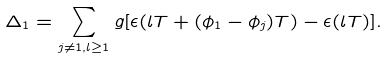Convert formula to latex. <formula><loc_0><loc_0><loc_500><loc_500>\Delta _ { 1 } = \sum _ { j \ne 1 , l \geq 1 } g [ \epsilon ( l T + ( \phi _ { 1 } - \phi _ { j } ) T ) - \epsilon ( l T ) ] .</formula> 